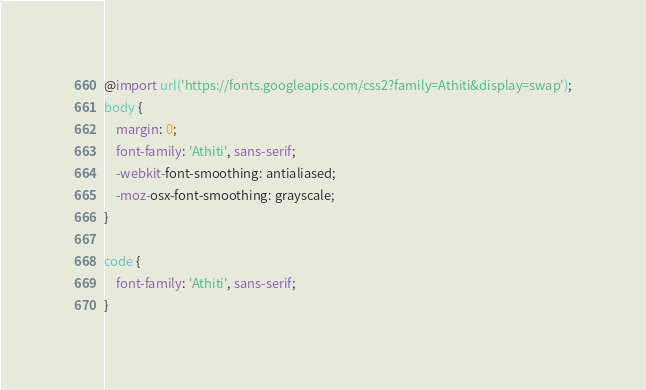<code> <loc_0><loc_0><loc_500><loc_500><_CSS_>@import url('https://fonts.googleapis.com/css2?family=Athiti&display=swap');
body {
    margin: 0;
    font-family: 'Athiti', sans-serif;
    -webkit-font-smoothing: antialiased;
    -moz-osx-font-smoothing: grayscale;
}

code {
    font-family: 'Athiti', sans-serif;
}
</code> 